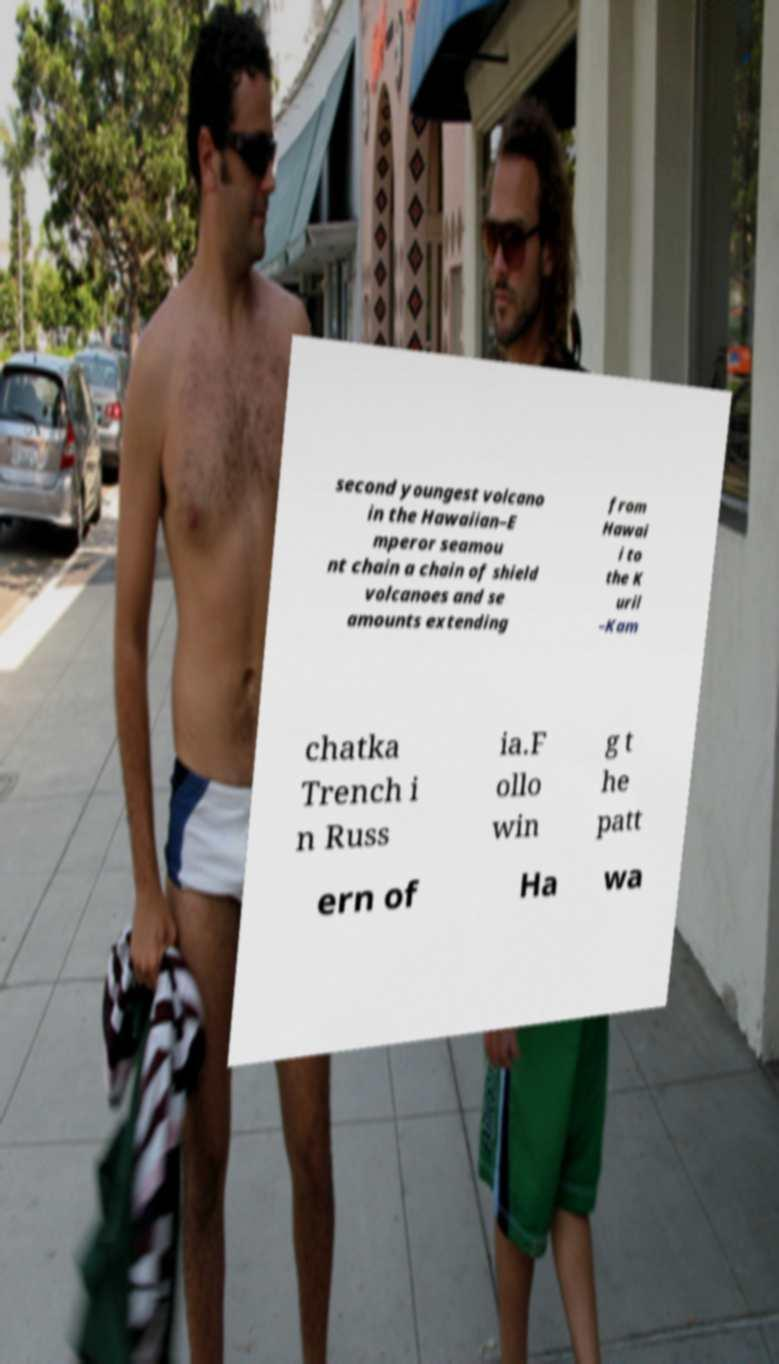Please read and relay the text visible in this image. What does it say? second youngest volcano in the Hawaiian–E mperor seamou nt chain a chain of shield volcanoes and se amounts extending from Hawai i to the K uril –Kam chatka Trench i n Russ ia.F ollo win g t he patt ern of Ha wa 